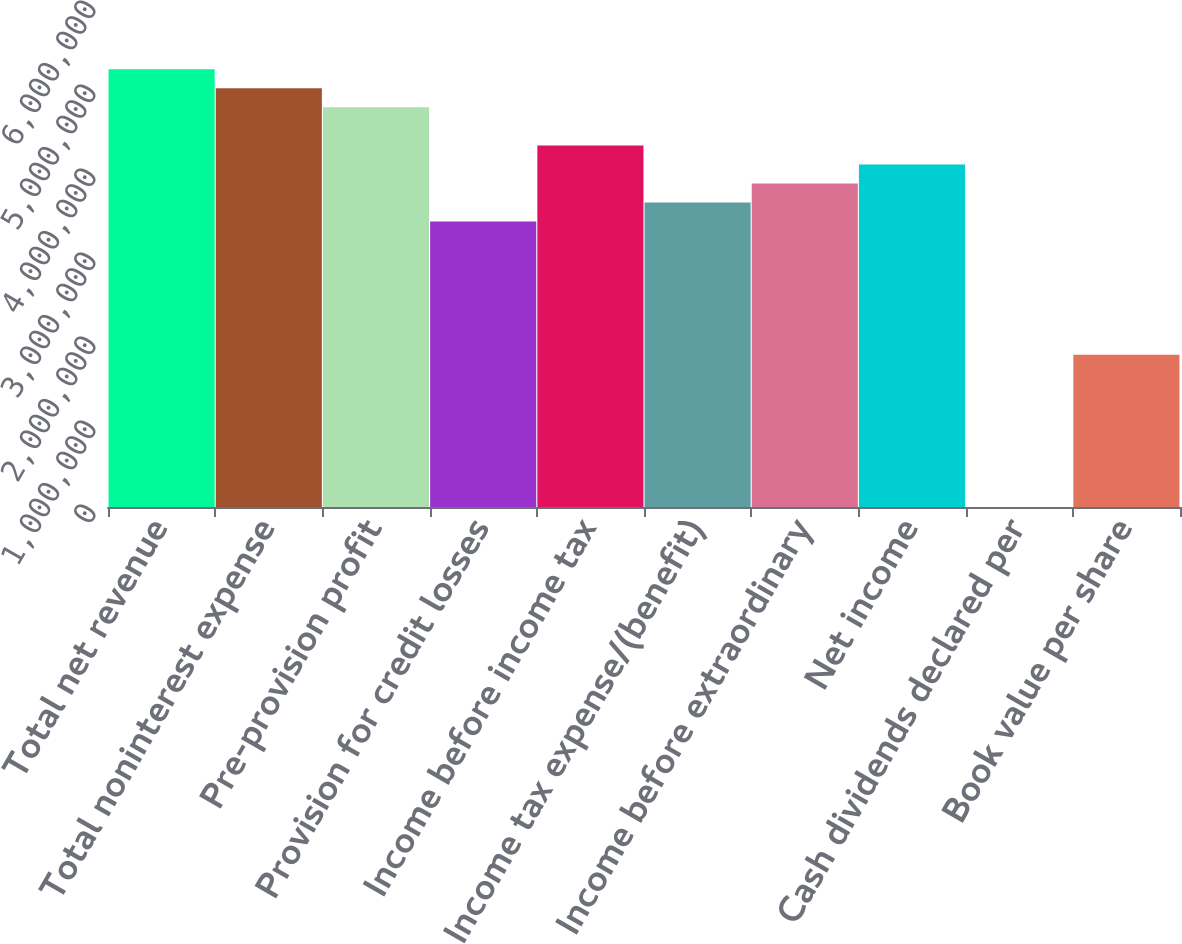<chart> <loc_0><loc_0><loc_500><loc_500><bar_chart><fcel>Total net revenue<fcel>Total noninterest expense<fcel>Pre-provision profit<fcel>Provision for credit losses<fcel>Income before income tax<fcel>Income tax expense/(benefit)<fcel>Income before extraordinary<fcel>Net income<fcel>Cash dividends declared per<fcel>Book value per share<nl><fcel>5.21132e+06<fcel>4.98474e+06<fcel>4.75816e+06<fcel>3.39869e+06<fcel>4.305e+06<fcel>3.62527e+06<fcel>3.85185e+06<fcel>4.07842e+06<fcel>1<fcel>1.81263e+06<nl></chart> 